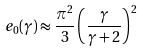Convert formula to latex. <formula><loc_0><loc_0><loc_500><loc_500>e _ { 0 } ( \gamma ) \approx \frac { \pi ^ { 2 } } { 3 } \left ( \frac { \gamma } { \gamma + 2 } \right ) ^ { 2 }</formula> 